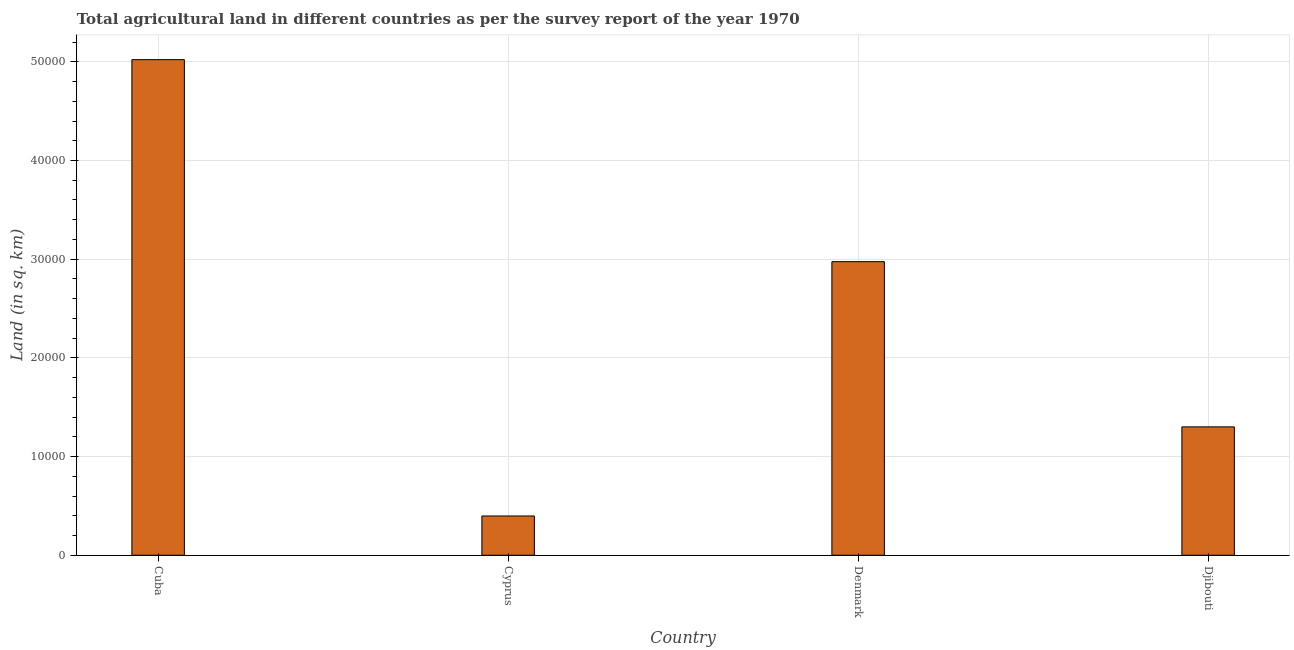Does the graph contain grids?
Give a very brief answer. Yes. What is the title of the graph?
Keep it short and to the point. Total agricultural land in different countries as per the survey report of the year 1970. What is the label or title of the Y-axis?
Provide a short and direct response. Land (in sq. km). What is the agricultural land in Cuba?
Your response must be concise. 5.02e+04. Across all countries, what is the maximum agricultural land?
Offer a very short reply. 5.02e+04. Across all countries, what is the minimum agricultural land?
Keep it short and to the point. 3980. In which country was the agricultural land maximum?
Make the answer very short. Cuba. In which country was the agricultural land minimum?
Offer a very short reply. Cyprus. What is the sum of the agricultural land?
Your answer should be compact. 9.70e+04. What is the difference between the agricultural land in Cyprus and Djibouti?
Make the answer very short. -9030. What is the average agricultural land per country?
Your answer should be very brief. 2.42e+04. What is the median agricultural land?
Provide a short and direct response. 2.14e+04. What is the ratio of the agricultural land in Denmark to that in Djibouti?
Your answer should be very brief. 2.29. Is the agricultural land in Cuba less than that in Djibouti?
Make the answer very short. No. Is the difference between the agricultural land in Cuba and Denmark greater than the difference between any two countries?
Offer a very short reply. No. What is the difference between the highest and the second highest agricultural land?
Make the answer very short. 2.05e+04. What is the difference between the highest and the lowest agricultural land?
Your answer should be compact. 4.62e+04. In how many countries, is the agricultural land greater than the average agricultural land taken over all countries?
Ensure brevity in your answer.  2. How many bars are there?
Keep it short and to the point. 4. What is the difference between two consecutive major ticks on the Y-axis?
Offer a terse response. 10000. Are the values on the major ticks of Y-axis written in scientific E-notation?
Ensure brevity in your answer.  No. What is the Land (in sq. km) of Cuba?
Offer a terse response. 5.02e+04. What is the Land (in sq. km) of Cyprus?
Provide a succinct answer. 3980. What is the Land (in sq. km) in Denmark?
Ensure brevity in your answer.  2.98e+04. What is the Land (in sq. km) in Djibouti?
Provide a succinct answer. 1.30e+04. What is the difference between the Land (in sq. km) in Cuba and Cyprus?
Keep it short and to the point. 4.62e+04. What is the difference between the Land (in sq. km) in Cuba and Denmark?
Ensure brevity in your answer.  2.05e+04. What is the difference between the Land (in sq. km) in Cuba and Djibouti?
Your response must be concise. 3.72e+04. What is the difference between the Land (in sq. km) in Cyprus and Denmark?
Your answer should be very brief. -2.58e+04. What is the difference between the Land (in sq. km) in Cyprus and Djibouti?
Your response must be concise. -9030. What is the difference between the Land (in sq. km) in Denmark and Djibouti?
Provide a short and direct response. 1.67e+04. What is the ratio of the Land (in sq. km) in Cuba to that in Cyprus?
Your answer should be compact. 12.62. What is the ratio of the Land (in sq. km) in Cuba to that in Denmark?
Offer a terse response. 1.69. What is the ratio of the Land (in sq. km) in Cuba to that in Djibouti?
Offer a very short reply. 3.86. What is the ratio of the Land (in sq. km) in Cyprus to that in Denmark?
Offer a very short reply. 0.13. What is the ratio of the Land (in sq. km) in Cyprus to that in Djibouti?
Your response must be concise. 0.31. What is the ratio of the Land (in sq. km) in Denmark to that in Djibouti?
Keep it short and to the point. 2.29. 